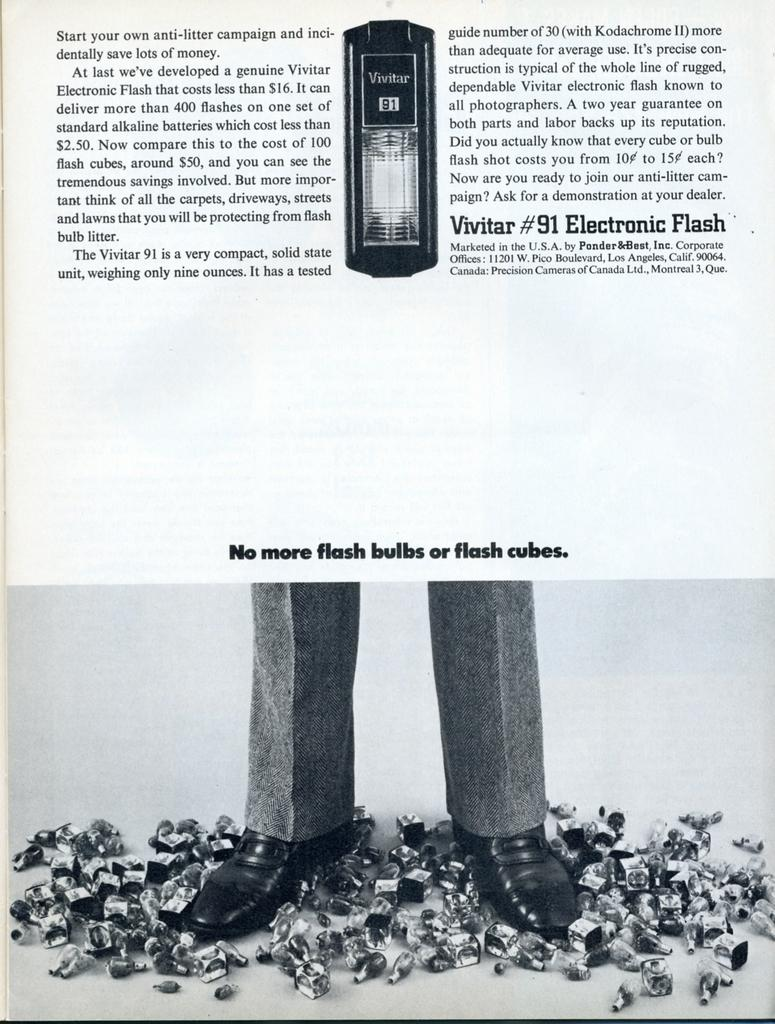What can be found at the top of the image? There is text and an image at the top of the image. What is depicted in the image at the top of the image? The image at the top of the image cannot be described without more information. What is happening in the picture at the bottom of the image? There is a picture of a person standing on objects at the bottom of the image. What text is present above the picture of the person? There is some text above the picture of the person, but its content cannot be determined without more information. What type of chess piece is the person in the image at the bottom of the image? There is no chess piece or chess game depicted in the image. What type of trade is being conducted in the image? There is no trade or any indication of a transaction in the image. 